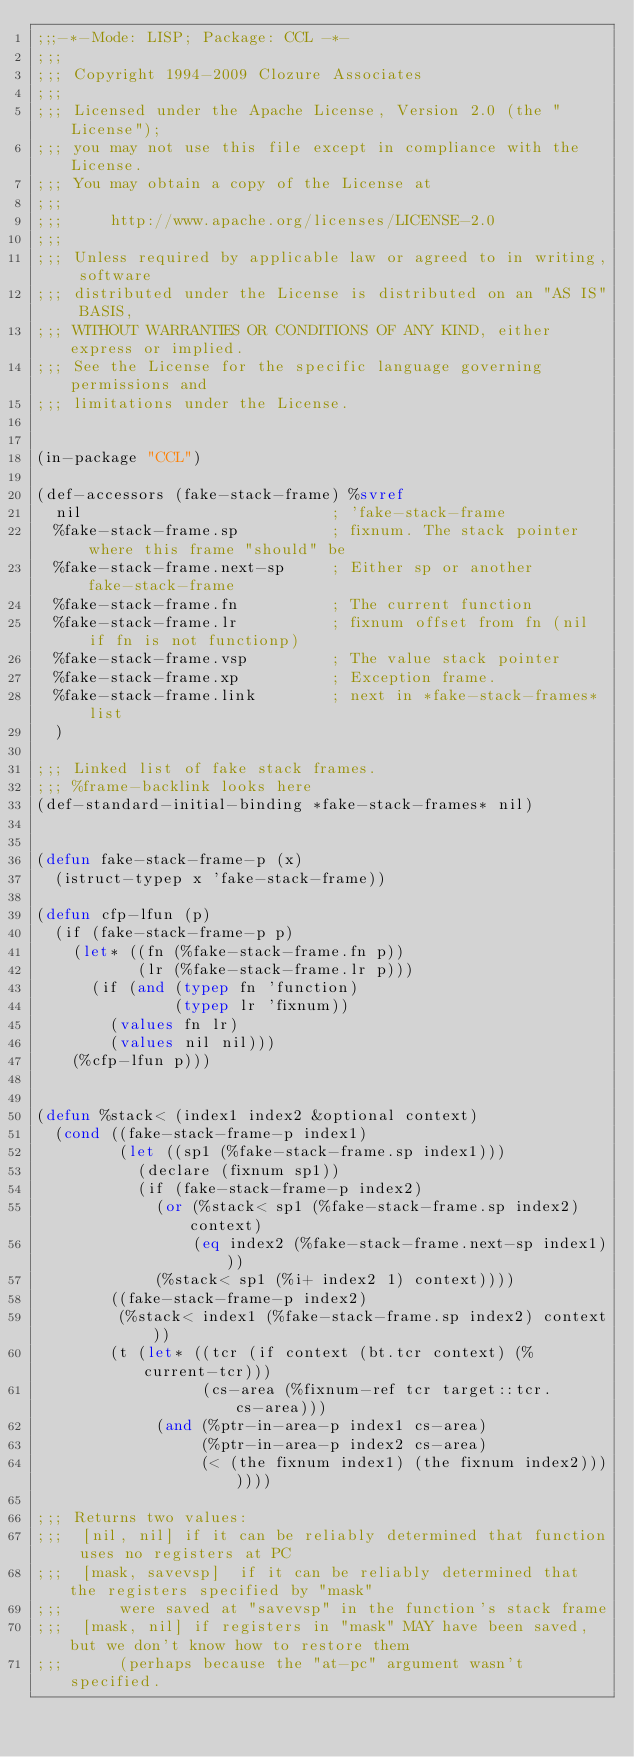Convert code to text. <code><loc_0><loc_0><loc_500><loc_500><_Lisp_>;;;-*-Mode: LISP; Package: CCL -*-
;;;
;;; Copyright 1994-2009 Clozure Associates
;;;
;;; Licensed under the Apache License, Version 2.0 (the "License");
;;; you may not use this file except in compliance with the License.
;;; You may obtain a copy of the License at
;;;
;;;     http://www.apache.org/licenses/LICENSE-2.0
;;;
;;; Unless required by applicable law or agreed to in writing, software
;;; distributed under the License is distributed on an "AS IS" BASIS,
;;; WITHOUT WARRANTIES OR CONDITIONS OF ANY KIND, either express or implied.
;;; See the License for the specific language governing permissions and
;;; limitations under the License.


(in-package "CCL")

(def-accessors (fake-stack-frame) %svref
  nil                           ; 'fake-stack-frame
  %fake-stack-frame.sp          ; fixnum. The stack pointer where this frame "should" be
  %fake-stack-frame.next-sp     ; Either sp or another fake-stack-frame
  %fake-stack-frame.fn          ; The current function
  %fake-stack-frame.lr          ; fixnum offset from fn (nil if fn is not functionp)
  %fake-stack-frame.vsp         ; The value stack pointer
  %fake-stack-frame.xp          ; Exception frame.
  %fake-stack-frame.link        ; next in *fake-stack-frames* list
  )

;;; Linked list of fake stack frames.
;;; %frame-backlink looks here
(def-standard-initial-binding *fake-stack-frames* nil)
  

(defun fake-stack-frame-p (x)
  (istruct-typep x 'fake-stack-frame))

(defun cfp-lfun (p)
  (if (fake-stack-frame-p p)
    (let* ((fn (%fake-stack-frame.fn p))
           (lr (%fake-stack-frame.lr p)))
      (if (and (typep fn 'function)
               (typep lr 'fixnum))
        (values fn lr)
        (values nil nil)))
    (%cfp-lfun p)))


(defun %stack< (index1 index2 &optional context)
  (cond ((fake-stack-frame-p index1)
         (let ((sp1 (%fake-stack-frame.sp index1)))
           (declare (fixnum sp1))
           (if (fake-stack-frame-p index2)
             (or (%stack< sp1 (%fake-stack-frame.sp index2) context)
                 (eq index2 (%fake-stack-frame.next-sp index1)))
             (%stack< sp1 (%i+ index2 1) context))))
        ((fake-stack-frame-p index2)
         (%stack< index1 (%fake-stack-frame.sp index2) context))
        (t (let* ((tcr (if context (bt.tcr context) (%current-tcr)))
                  (cs-area (%fixnum-ref tcr target::tcr.cs-area)))
             (and (%ptr-in-area-p index1 cs-area)
                  (%ptr-in-area-p index2 cs-area)
                  (< (the fixnum index1) (the fixnum index2)))))))

;;; Returns two values:
;;;  [nil, nil] if it can be reliably determined that function uses no registers at PC
;;;  [mask, savevsp]  if it can be reliably determined that the registers specified by "mask"
;;;      were saved at "savevsp" in the function's stack frame
;;;  [mask, nil] if registers in "mask" MAY have been saved, but we don't know how to restore them
;;;      (perhaps because the "at-pc" argument wasn't specified.

</code> 